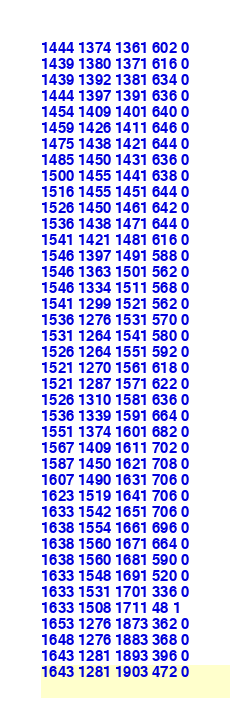<code> <loc_0><loc_0><loc_500><loc_500><_SML_>1444 1374 1361 602 0
1439 1380 1371 616 0
1439 1392 1381 634 0
1444 1397 1391 636 0
1454 1409 1401 640 0
1459 1426 1411 646 0
1475 1438 1421 644 0
1485 1450 1431 636 0
1500 1455 1441 638 0
1516 1455 1451 644 0
1526 1450 1461 642 0
1536 1438 1471 644 0
1541 1421 1481 616 0
1546 1397 1491 588 0
1546 1363 1501 562 0
1546 1334 1511 568 0
1541 1299 1521 562 0
1536 1276 1531 570 0
1531 1264 1541 580 0
1526 1264 1551 592 0
1521 1270 1561 618 0
1521 1287 1571 622 0
1526 1310 1581 636 0
1536 1339 1591 664 0
1551 1374 1601 682 0
1567 1409 1611 702 0
1587 1450 1621 708 0
1607 1490 1631 706 0
1623 1519 1641 706 0
1633 1542 1651 706 0
1638 1554 1661 696 0
1638 1560 1671 664 0
1638 1560 1681 590 0
1633 1548 1691 520 0
1633 1531 1701 336 0
1633 1508 1711 48 1
1653 1276 1873 362 0
1648 1276 1883 368 0
1643 1281 1893 396 0
1643 1281 1903 472 0</code> 